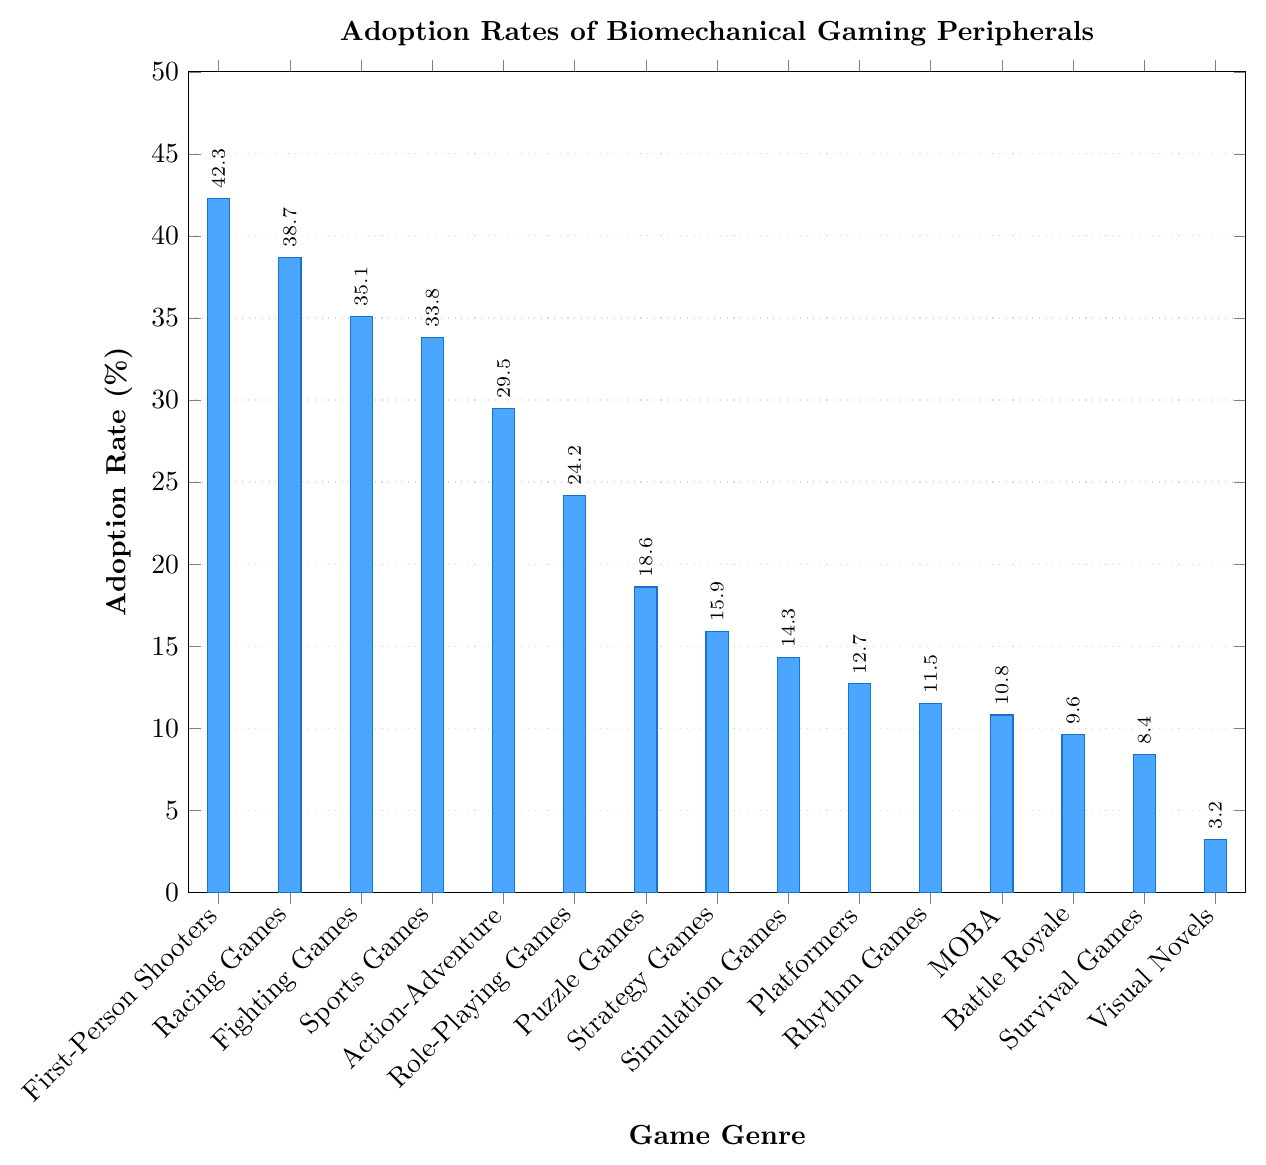What's the genre with the highest adoption rate of biomechanical gaming peripherals? The bar for First-Person Shooters is the tallest, indicating the highest adoption rate of biomechanical gaming peripherals.
Answer: First-Person Shooters Which games have an adoption rate above 30%? Look at the bars and identify which ones exceed the 30% mark: First-Person Shooters, Racing Games, Fighting Games, and Sports Games.
Answer: First-Person Shooters, Racing Games, Fighting Games, Sports Games What is the difference in adoption rates between Rhythm Games and MOBA? The adoption rate for Rhythm Games is 11.5% and for MOBA is 10.8%. The difference is 11.5 - 10.8 = 0.7%.
Answer: 0.7% How much higher is the adoption rate of First-Person Shooters compared to Puzzle Games? The adoption rate for First-Person Shooters is 42.3% and for Puzzle Games is 18.6%. The difference is 42.3 - 18.6 = 23.7%.
Answer: 23.7% Which genre has the lowest adoption rate of biomechanical gaming peripherals? The shortest bar represents Visual Novels, indicating the lowest adoption rate.
Answer: Visual Novels What is the average adoption rate across all genres? Sum all adoption rates and divide by the number of genres: (42.3 + 38.7 + 35.1 + 33.8 + 29.5 + 24.2 + 18.6 + 15.9 + 14.3 + 12.7 + 11.5 + 10.8 + 9.6 + 8.4 + 3.2) / 15 ≈ 21.1
Answer: 21.1 Which genres have adoption rates between 10% and 20%? Identify bars that fall within the 10% to 20% range: Puzzle Games, Strategy Games, Simulation Games, Platformers, Rhythm Games, and MOBA.
Answer: Puzzle Games, Strategy Games, Simulation Games, Platformers, Rhythm Games, MOBA What's the median adoption rate across all genres? Order the adoption rates and find the middle value: Ordered rates: 3.2, 8.4, 9.6, 10.8, 11.5, 12.7, 14.3, 15.9, 18.6, 24.2, 29.5, 33.8, 35.1, 38.7, 42.3. The middle value is 15.9 (Strategy Games).
Answer: 15.9 Compare the adoption rates between Racing Games and Role-Playing Games. Which one is higher and by how much? Racing Games have an adoption rate of 38.7% and Role-Playing Games have 24.2%. The difference is 38.7 - 24.2 = 14.5%.
Answer: Racing Games, 14.5% What is the sum of adoption rates for Battle Royale and Survival Games? Add the adoption rates of both genres: 9.6 + 8.4 = 18.
Answer: 18 